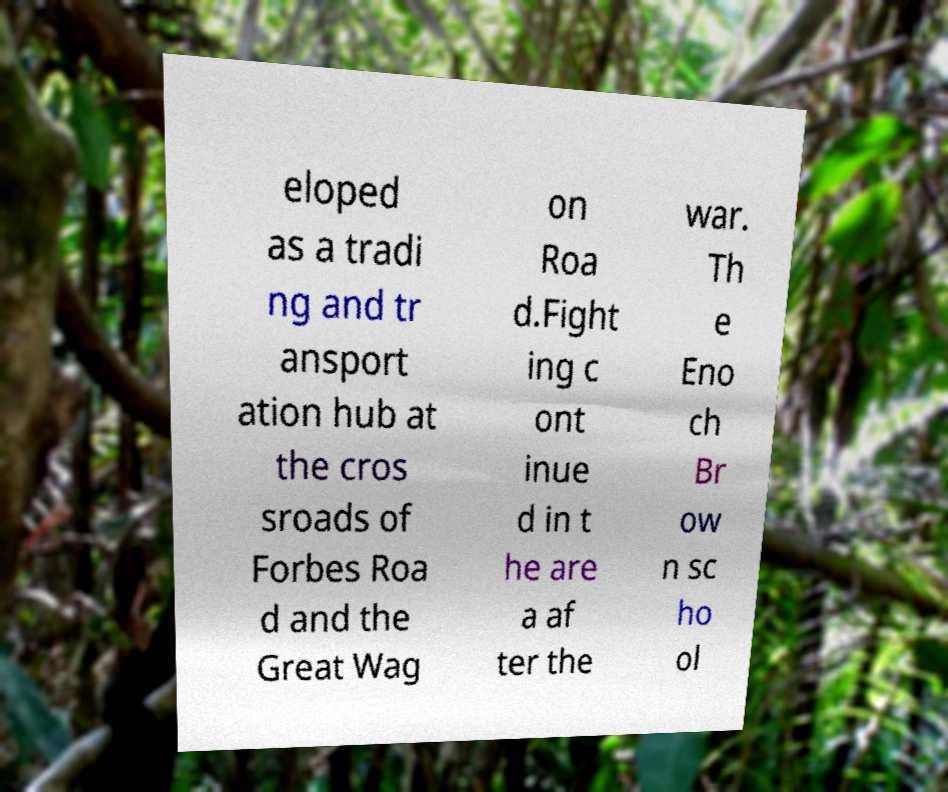What messages or text are displayed in this image? I need them in a readable, typed format. eloped as a tradi ng and tr ansport ation hub at the cros sroads of Forbes Roa d and the Great Wag on Roa d.Fight ing c ont inue d in t he are a af ter the war. Th e Eno ch Br ow n sc ho ol 